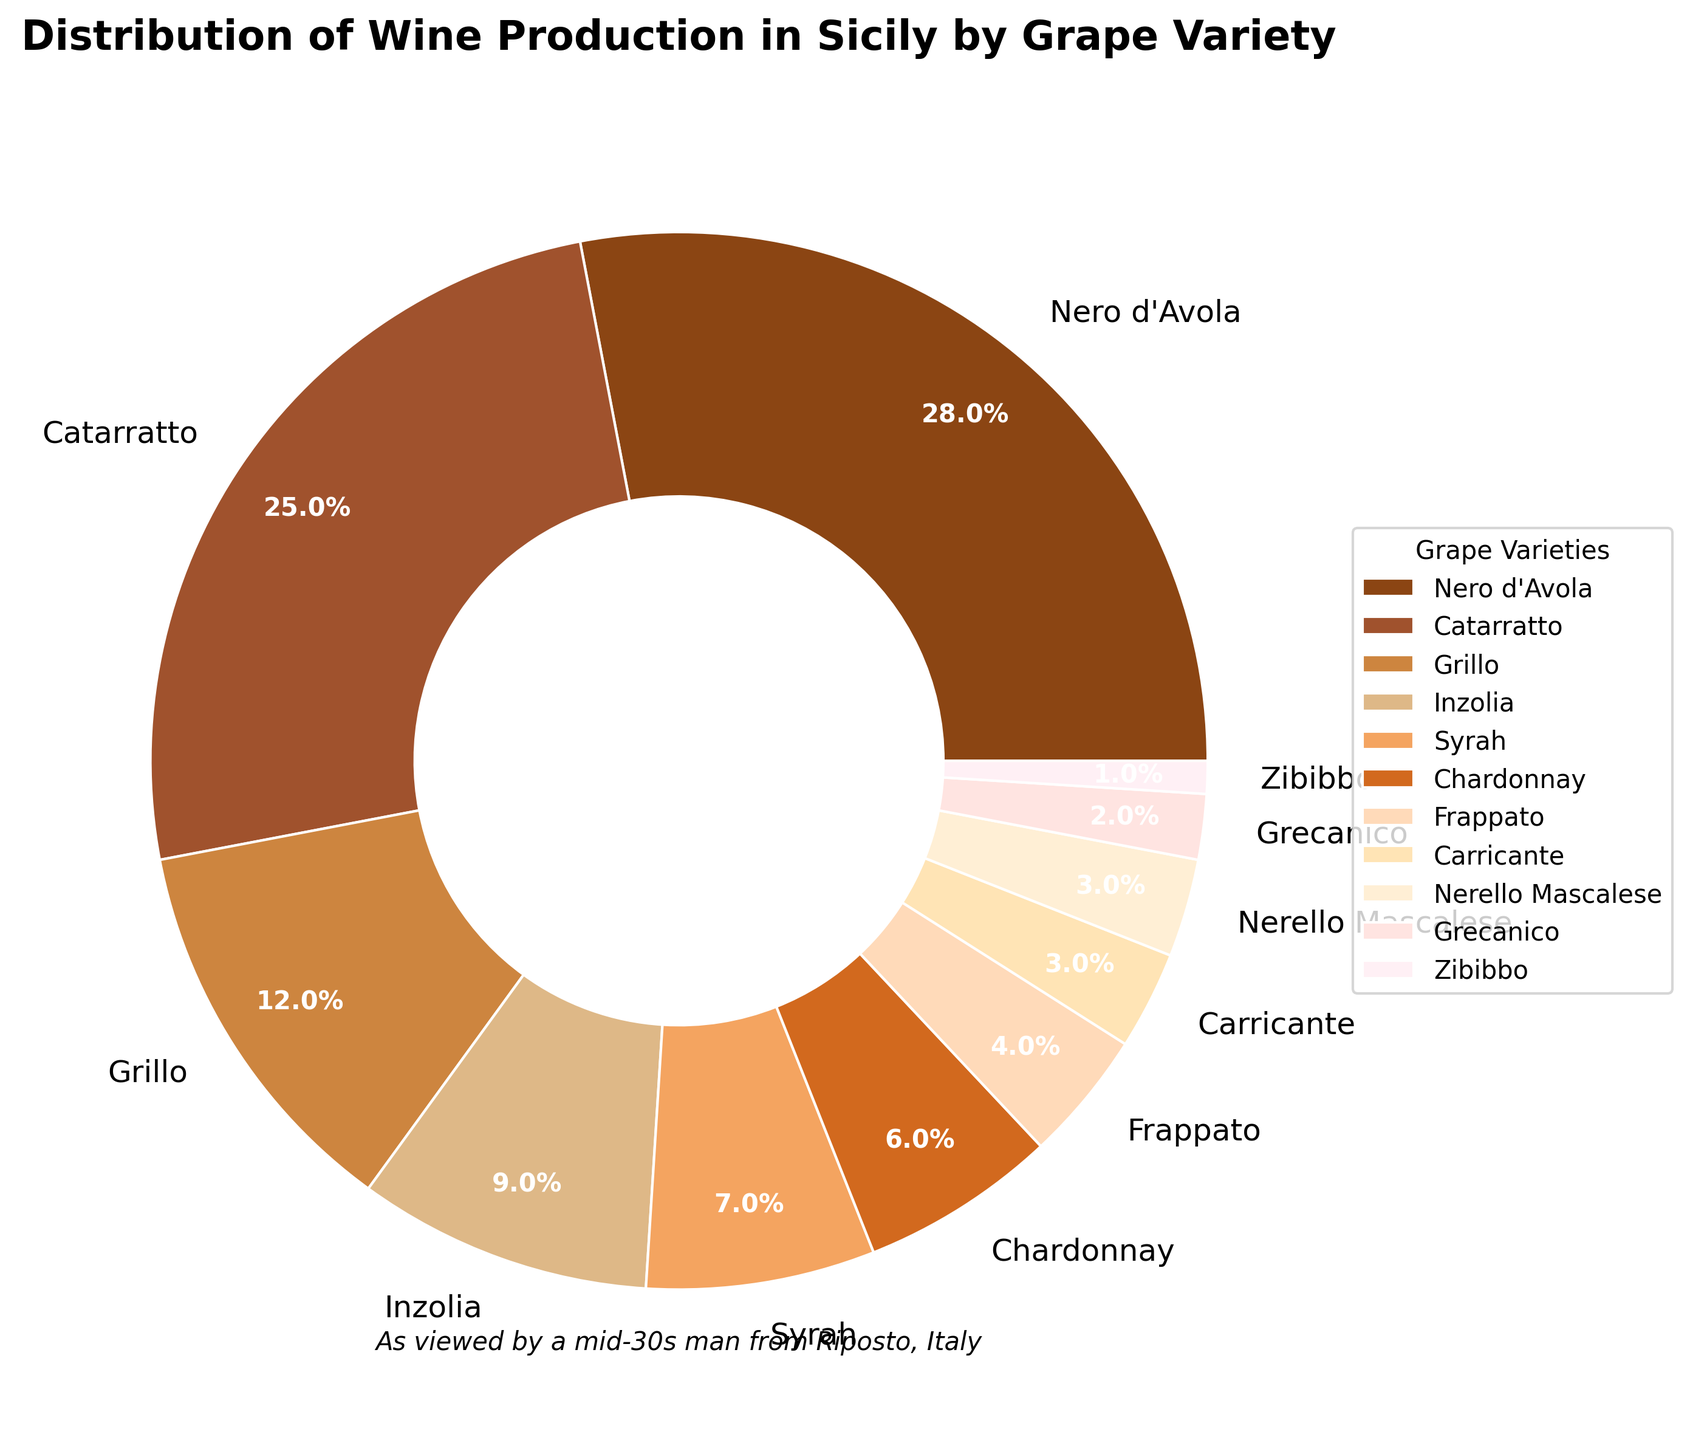Which grape variety has the highest percentage of wine production? The grape variety with the highest percentage can be identified by looking at the largest wedge in the pie chart. Nero d'Avola has the largest wedge with 28%.
Answer: Nero d'Avola What is the total percentage of wine production by Catarratto and Grillo? To find the total percentage, add the percentage of Catarratto (25%) and Grillo (12%) together. 25% + 12% = 37%.
Answer: 37% How does the percentage of Syrah compare to Chardonnay? Syrah has a 7% share while Chardonnay has a 6% share. Comparing these, Syrah has a 1% larger share than Chardonnay.
Answer: Syrah is 1% larger Which grape varieties make up less than 5% of the wine production each? Grape varieties with wedges representing less than 5% each are Frappato (4%), Carricante (3%), Nerello Mascalese (3%), Grecanico (2%), and Zibibbo (1%).
Answer: Frappato, Carricante, Nerello Mascalese, Grecanico, Zibibbo What is the combined percentage of Inzolia, Syrah, and Chardonnay? To find the combined percentage, sum the percentages of Inzolia (9%), Syrah (7%), and Chardonnay (6%). 9% + 7% + 6% = 22%.
Answer: 22% Out of Nero d'Avola, Catarratto, and Grillo, which has the smallest percentage? Among the three, Grillo has the smallest percentage with 12% compared to Nero d'Avola (28%) and Catarratto (25%).
Answer: Grillo What is the difference in wine production percentage between Carricante and Grecanico? Subtract Grecanico's percentage (2%) from Carricante's percentage (3%). 3% - 2% = 1%.
Answer: 1% How much smaller is the percentage of Zibibbo compared to the average percentage of Nero d'Avola, Catarratto, and Grillo? First, calculate the average percentage of Nero d'Avola, Catarratto, and Grillo: (28% + 25% + 12%) / 3 = 21.67%. Then find the difference by subtracting Zibibbo's percentage (1%) from this average: 21.67% - 1% = 20.67%.
Answer: 20.67% Which grape variety is visually represented with the darkest shade in the pie chart? The visually darkest shade corresponds to the grape variety plotted first (the largest wedge starting from the top). This largest portion belongs to Nero d'Avola.
Answer: Nero d'Avola 